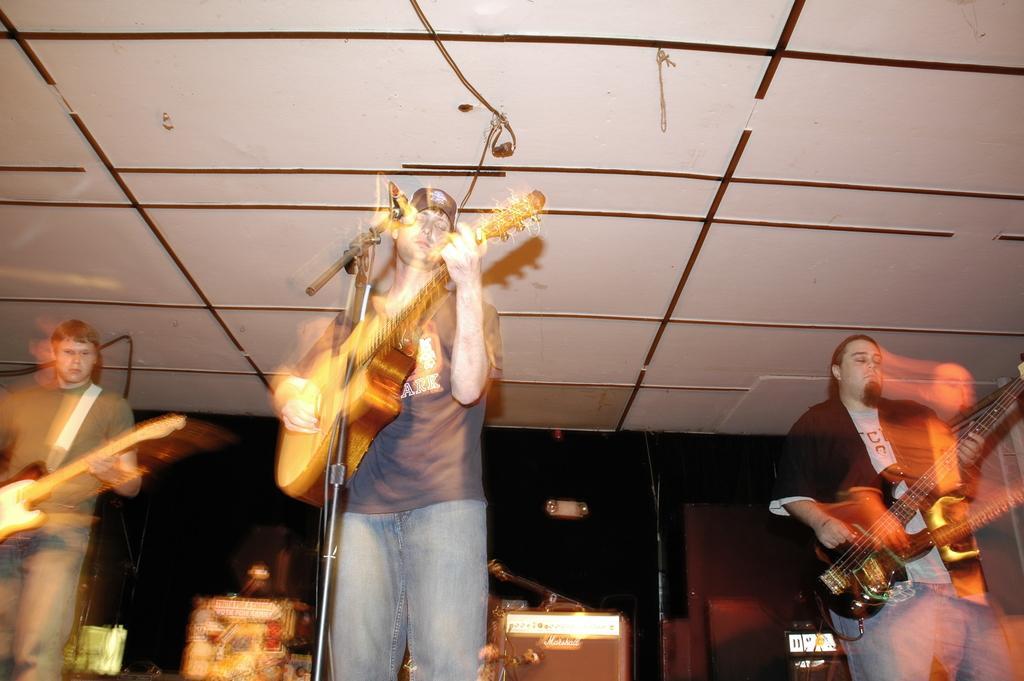Please provide a concise description of this image. In this picture we can see three person playing guitar and middle person is singing on mic and the background we can see boxes, wall and this picture is blur. 